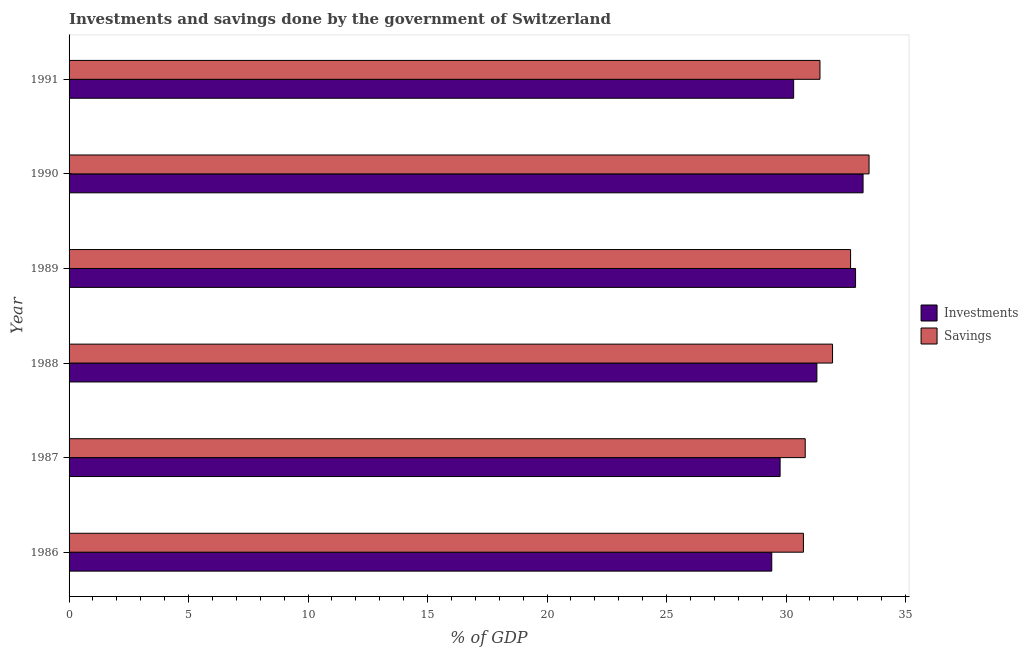Are the number of bars on each tick of the Y-axis equal?
Make the answer very short. Yes. How many bars are there on the 6th tick from the bottom?
Your response must be concise. 2. What is the label of the 1st group of bars from the top?
Offer a very short reply. 1991. In how many cases, is the number of bars for a given year not equal to the number of legend labels?
Provide a succinct answer. 0. What is the savings of government in 1988?
Your response must be concise. 31.95. Across all years, what is the maximum investments of government?
Provide a short and direct response. 33.22. Across all years, what is the minimum savings of government?
Provide a succinct answer. 30.73. In which year was the savings of government maximum?
Offer a very short reply. 1990. In which year was the investments of government minimum?
Offer a terse response. 1986. What is the total investments of government in the graph?
Provide a succinct answer. 186.91. What is the difference between the savings of government in 1988 and that in 1989?
Your answer should be very brief. -0.76. What is the difference between the investments of government in 1988 and the savings of government in 1987?
Make the answer very short. 0.49. What is the average savings of government per year?
Ensure brevity in your answer.  31.85. In the year 1987, what is the difference between the investments of government and savings of government?
Your answer should be compact. -1.05. In how many years, is the savings of government greater than 20 %?
Offer a terse response. 6. What is the ratio of the savings of government in 1987 to that in 1988?
Offer a very short reply. 0.96. Is the savings of government in 1990 less than that in 1991?
Keep it short and to the point. No. What is the difference between the highest and the second highest investments of government?
Offer a very short reply. 0.31. What is the difference between the highest and the lowest savings of government?
Give a very brief answer. 2.75. In how many years, is the investments of government greater than the average investments of government taken over all years?
Keep it short and to the point. 3. What does the 2nd bar from the top in 1990 represents?
Give a very brief answer. Investments. What does the 2nd bar from the bottom in 1990 represents?
Your answer should be compact. Savings. Are all the bars in the graph horizontal?
Provide a succinct answer. Yes. Where does the legend appear in the graph?
Make the answer very short. Center right. How many legend labels are there?
Provide a succinct answer. 2. How are the legend labels stacked?
Your answer should be very brief. Vertical. What is the title of the graph?
Provide a succinct answer. Investments and savings done by the government of Switzerland. What is the label or title of the X-axis?
Make the answer very short. % of GDP. What is the label or title of the Y-axis?
Your answer should be very brief. Year. What is the % of GDP of Investments in 1986?
Give a very brief answer. 29.4. What is the % of GDP in Savings in 1986?
Provide a succinct answer. 30.73. What is the % of GDP of Investments in 1987?
Provide a succinct answer. 29.75. What is the % of GDP of Savings in 1987?
Provide a succinct answer. 30.8. What is the % of GDP of Investments in 1988?
Make the answer very short. 31.29. What is the % of GDP in Savings in 1988?
Provide a succinct answer. 31.95. What is the % of GDP of Investments in 1989?
Offer a very short reply. 32.91. What is the % of GDP of Savings in 1989?
Your response must be concise. 32.7. What is the % of GDP of Investments in 1990?
Your answer should be compact. 33.22. What is the % of GDP in Savings in 1990?
Your response must be concise. 33.48. What is the % of GDP of Investments in 1991?
Offer a terse response. 30.32. What is the % of GDP of Savings in 1991?
Offer a very short reply. 31.42. Across all years, what is the maximum % of GDP in Investments?
Your response must be concise. 33.22. Across all years, what is the maximum % of GDP in Savings?
Your answer should be compact. 33.48. Across all years, what is the minimum % of GDP in Investments?
Provide a short and direct response. 29.4. Across all years, what is the minimum % of GDP of Savings?
Your answer should be very brief. 30.73. What is the total % of GDP of Investments in the graph?
Give a very brief answer. 186.91. What is the total % of GDP in Savings in the graph?
Make the answer very short. 191.08. What is the difference between the % of GDP in Investments in 1986 and that in 1987?
Offer a very short reply. -0.35. What is the difference between the % of GDP of Savings in 1986 and that in 1987?
Provide a short and direct response. -0.08. What is the difference between the % of GDP in Investments in 1986 and that in 1988?
Provide a succinct answer. -1.89. What is the difference between the % of GDP of Savings in 1986 and that in 1988?
Offer a very short reply. -1.22. What is the difference between the % of GDP in Investments in 1986 and that in 1989?
Your answer should be very brief. -3.51. What is the difference between the % of GDP in Savings in 1986 and that in 1989?
Keep it short and to the point. -1.97. What is the difference between the % of GDP in Investments in 1986 and that in 1990?
Provide a succinct answer. -3.82. What is the difference between the % of GDP in Savings in 1986 and that in 1990?
Offer a very short reply. -2.75. What is the difference between the % of GDP of Investments in 1986 and that in 1991?
Your response must be concise. -0.92. What is the difference between the % of GDP of Savings in 1986 and that in 1991?
Give a very brief answer. -0.69. What is the difference between the % of GDP in Investments in 1987 and that in 1988?
Provide a short and direct response. -1.54. What is the difference between the % of GDP of Savings in 1987 and that in 1988?
Your answer should be very brief. -1.14. What is the difference between the % of GDP of Investments in 1987 and that in 1989?
Provide a succinct answer. -3.16. What is the difference between the % of GDP in Savings in 1987 and that in 1989?
Your answer should be compact. -1.9. What is the difference between the % of GDP in Investments in 1987 and that in 1990?
Your answer should be very brief. -3.47. What is the difference between the % of GDP of Savings in 1987 and that in 1990?
Provide a short and direct response. -2.67. What is the difference between the % of GDP of Investments in 1987 and that in 1991?
Ensure brevity in your answer.  -0.57. What is the difference between the % of GDP of Savings in 1987 and that in 1991?
Your answer should be compact. -0.62. What is the difference between the % of GDP of Investments in 1988 and that in 1989?
Keep it short and to the point. -1.62. What is the difference between the % of GDP in Savings in 1988 and that in 1989?
Your response must be concise. -0.75. What is the difference between the % of GDP of Investments in 1988 and that in 1990?
Offer a very short reply. -1.93. What is the difference between the % of GDP of Savings in 1988 and that in 1990?
Give a very brief answer. -1.53. What is the difference between the % of GDP of Investments in 1988 and that in 1991?
Offer a terse response. 0.97. What is the difference between the % of GDP of Savings in 1988 and that in 1991?
Offer a very short reply. 0.53. What is the difference between the % of GDP in Investments in 1989 and that in 1990?
Keep it short and to the point. -0.31. What is the difference between the % of GDP in Savings in 1989 and that in 1990?
Make the answer very short. -0.77. What is the difference between the % of GDP of Investments in 1989 and that in 1991?
Give a very brief answer. 2.59. What is the difference between the % of GDP of Savings in 1989 and that in 1991?
Offer a terse response. 1.28. What is the difference between the % of GDP in Investments in 1990 and that in 1991?
Keep it short and to the point. 2.9. What is the difference between the % of GDP of Savings in 1990 and that in 1991?
Ensure brevity in your answer.  2.05. What is the difference between the % of GDP in Investments in 1986 and the % of GDP in Savings in 1987?
Ensure brevity in your answer.  -1.4. What is the difference between the % of GDP of Investments in 1986 and the % of GDP of Savings in 1988?
Your answer should be very brief. -2.54. What is the difference between the % of GDP of Investments in 1986 and the % of GDP of Savings in 1989?
Ensure brevity in your answer.  -3.3. What is the difference between the % of GDP in Investments in 1986 and the % of GDP in Savings in 1990?
Your response must be concise. -4.07. What is the difference between the % of GDP of Investments in 1986 and the % of GDP of Savings in 1991?
Your answer should be very brief. -2.02. What is the difference between the % of GDP in Investments in 1987 and the % of GDP in Savings in 1988?
Offer a terse response. -2.19. What is the difference between the % of GDP in Investments in 1987 and the % of GDP in Savings in 1989?
Ensure brevity in your answer.  -2.95. What is the difference between the % of GDP of Investments in 1987 and the % of GDP of Savings in 1990?
Give a very brief answer. -3.72. What is the difference between the % of GDP of Investments in 1987 and the % of GDP of Savings in 1991?
Your response must be concise. -1.67. What is the difference between the % of GDP in Investments in 1988 and the % of GDP in Savings in 1989?
Provide a succinct answer. -1.41. What is the difference between the % of GDP of Investments in 1988 and the % of GDP of Savings in 1990?
Ensure brevity in your answer.  -2.18. What is the difference between the % of GDP in Investments in 1988 and the % of GDP in Savings in 1991?
Your answer should be compact. -0.13. What is the difference between the % of GDP of Investments in 1989 and the % of GDP of Savings in 1990?
Provide a short and direct response. -0.56. What is the difference between the % of GDP of Investments in 1989 and the % of GDP of Savings in 1991?
Make the answer very short. 1.49. What is the difference between the % of GDP of Investments in 1990 and the % of GDP of Savings in 1991?
Provide a short and direct response. 1.8. What is the average % of GDP of Investments per year?
Offer a very short reply. 31.15. What is the average % of GDP of Savings per year?
Your answer should be compact. 31.85. In the year 1986, what is the difference between the % of GDP in Investments and % of GDP in Savings?
Ensure brevity in your answer.  -1.32. In the year 1987, what is the difference between the % of GDP of Investments and % of GDP of Savings?
Your answer should be compact. -1.05. In the year 1988, what is the difference between the % of GDP in Investments and % of GDP in Savings?
Offer a terse response. -0.66. In the year 1989, what is the difference between the % of GDP in Investments and % of GDP in Savings?
Provide a short and direct response. 0.21. In the year 1990, what is the difference between the % of GDP in Investments and % of GDP in Savings?
Your response must be concise. -0.25. In the year 1991, what is the difference between the % of GDP of Investments and % of GDP of Savings?
Give a very brief answer. -1.1. What is the ratio of the % of GDP of Investments in 1986 to that in 1987?
Provide a succinct answer. 0.99. What is the ratio of the % of GDP of Investments in 1986 to that in 1988?
Your answer should be compact. 0.94. What is the ratio of the % of GDP of Savings in 1986 to that in 1988?
Ensure brevity in your answer.  0.96. What is the ratio of the % of GDP in Investments in 1986 to that in 1989?
Your answer should be compact. 0.89. What is the ratio of the % of GDP in Savings in 1986 to that in 1989?
Provide a short and direct response. 0.94. What is the ratio of the % of GDP of Investments in 1986 to that in 1990?
Provide a short and direct response. 0.89. What is the ratio of the % of GDP of Savings in 1986 to that in 1990?
Ensure brevity in your answer.  0.92. What is the ratio of the % of GDP in Investments in 1986 to that in 1991?
Your answer should be very brief. 0.97. What is the ratio of the % of GDP in Investments in 1987 to that in 1988?
Give a very brief answer. 0.95. What is the ratio of the % of GDP of Savings in 1987 to that in 1988?
Keep it short and to the point. 0.96. What is the ratio of the % of GDP in Investments in 1987 to that in 1989?
Give a very brief answer. 0.9. What is the ratio of the % of GDP of Savings in 1987 to that in 1989?
Provide a short and direct response. 0.94. What is the ratio of the % of GDP of Investments in 1987 to that in 1990?
Make the answer very short. 0.9. What is the ratio of the % of GDP of Savings in 1987 to that in 1990?
Provide a succinct answer. 0.92. What is the ratio of the % of GDP in Investments in 1987 to that in 1991?
Your answer should be very brief. 0.98. What is the ratio of the % of GDP in Savings in 1987 to that in 1991?
Your answer should be compact. 0.98. What is the ratio of the % of GDP in Investments in 1988 to that in 1989?
Give a very brief answer. 0.95. What is the ratio of the % of GDP in Savings in 1988 to that in 1989?
Your response must be concise. 0.98. What is the ratio of the % of GDP of Investments in 1988 to that in 1990?
Give a very brief answer. 0.94. What is the ratio of the % of GDP in Savings in 1988 to that in 1990?
Your answer should be compact. 0.95. What is the ratio of the % of GDP of Investments in 1988 to that in 1991?
Make the answer very short. 1.03. What is the ratio of the % of GDP in Savings in 1988 to that in 1991?
Offer a terse response. 1.02. What is the ratio of the % of GDP of Investments in 1989 to that in 1990?
Your answer should be compact. 0.99. What is the ratio of the % of GDP of Savings in 1989 to that in 1990?
Give a very brief answer. 0.98. What is the ratio of the % of GDP of Investments in 1989 to that in 1991?
Provide a short and direct response. 1.09. What is the ratio of the % of GDP of Savings in 1989 to that in 1991?
Your answer should be compact. 1.04. What is the ratio of the % of GDP in Investments in 1990 to that in 1991?
Ensure brevity in your answer.  1.1. What is the ratio of the % of GDP in Savings in 1990 to that in 1991?
Your answer should be compact. 1.07. What is the difference between the highest and the second highest % of GDP in Investments?
Make the answer very short. 0.31. What is the difference between the highest and the second highest % of GDP of Savings?
Your response must be concise. 0.77. What is the difference between the highest and the lowest % of GDP in Investments?
Your answer should be compact. 3.82. What is the difference between the highest and the lowest % of GDP in Savings?
Ensure brevity in your answer.  2.75. 